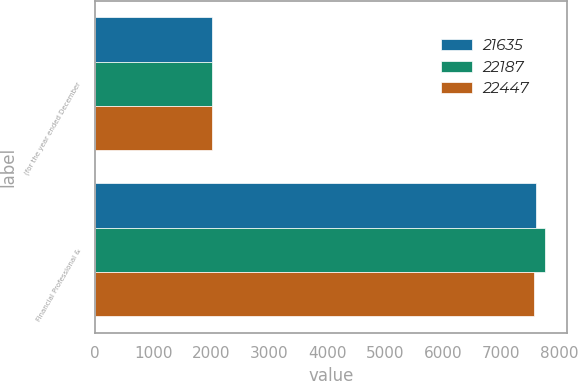<chart> <loc_0><loc_0><loc_500><loc_500><stacked_bar_chart><ecel><fcel>(for the year ended December<fcel>Financial Professional &<nl><fcel>21635<fcel>2012<fcel>7594<nl><fcel>22187<fcel>2011<fcel>7745<nl><fcel>22447<fcel>2010<fcel>7567<nl></chart> 